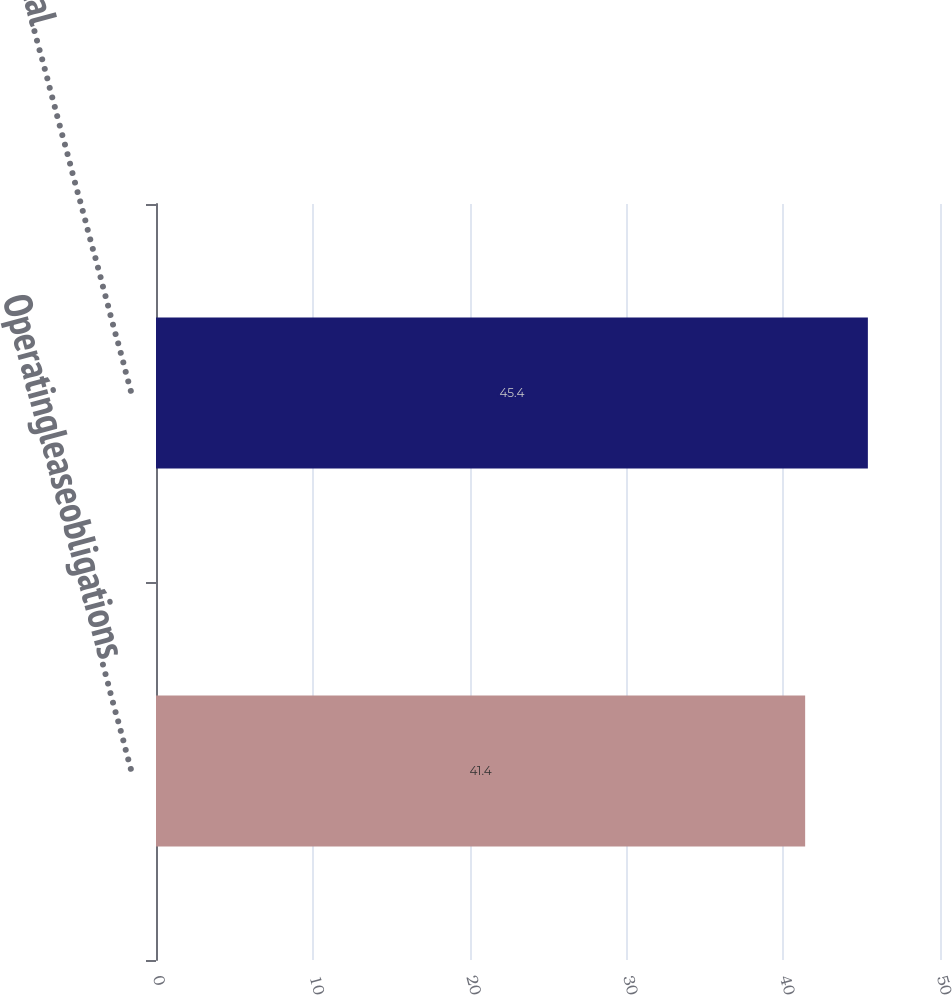Convert chart to OTSL. <chart><loc_0><loc_0><loc_500><loc_500><bar_chart><fcel>Operatingleaseobligations…………<fcel>Total…………………………………<nl><fcel>41.4<fcel>45.4<nl></chart> 